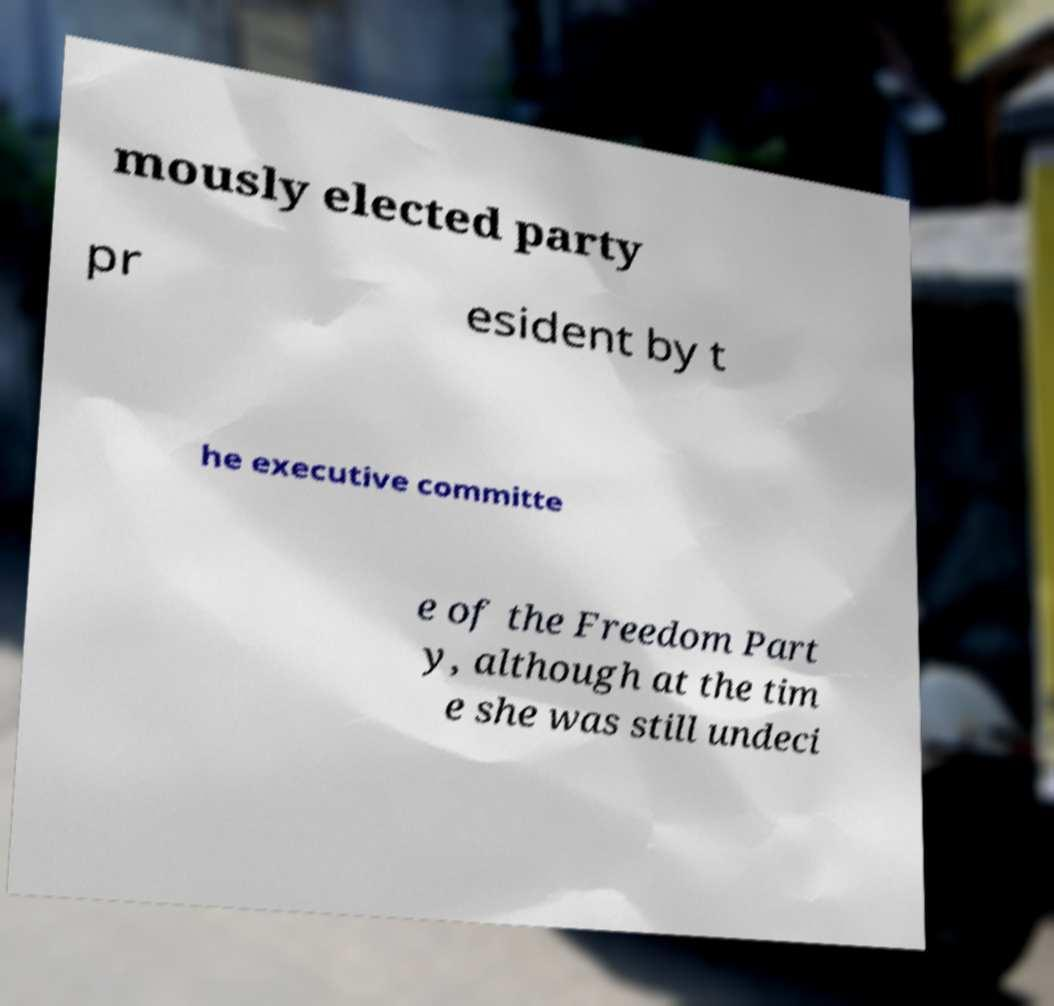Please identify and transcribe the text found in this image. mously elected party pr esident by t he executive committe e of the Freedom Part y, although at the tim e she was still undeci 